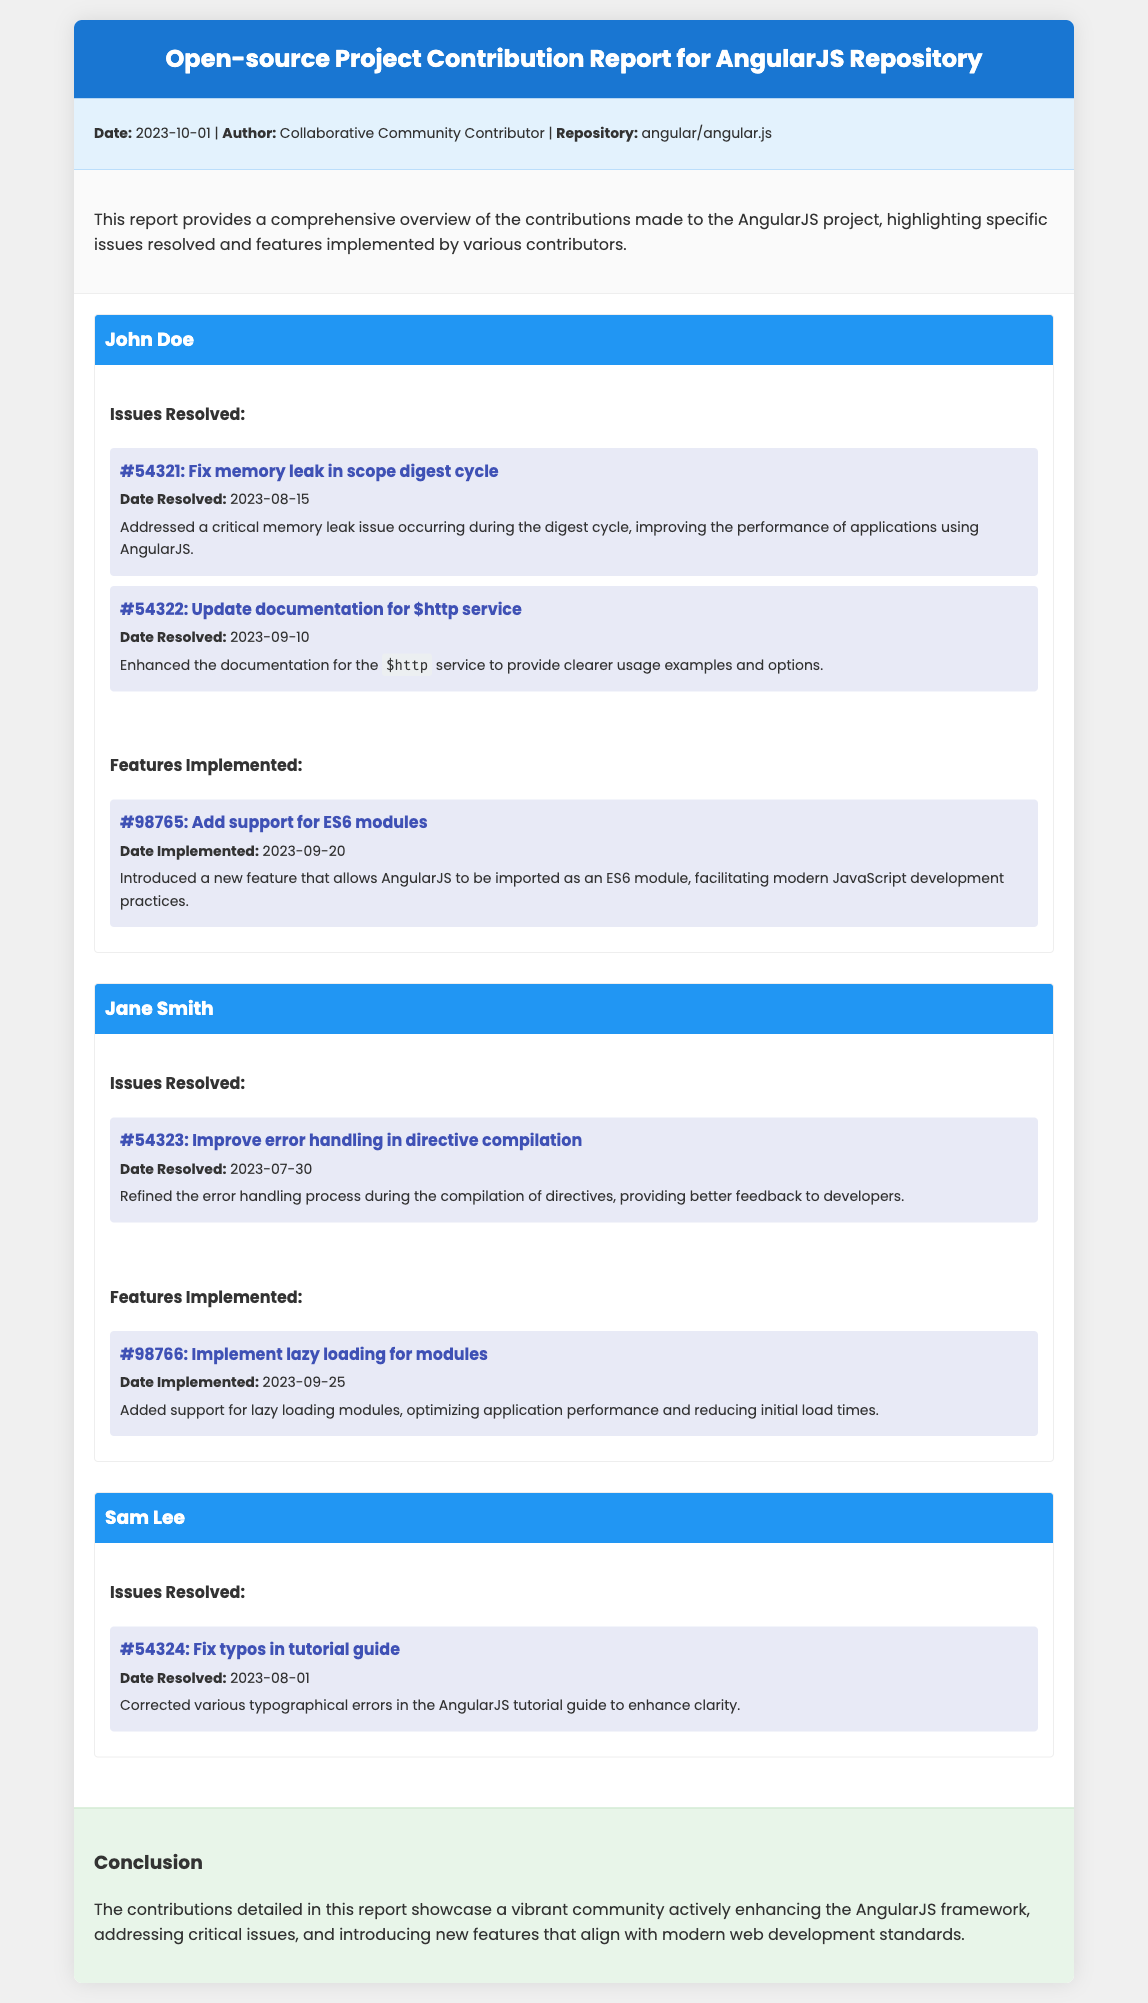What is the date of the report? The date of the report is clearly stated in the meta-info section.
Answer: 2023-10-01 Who resolved the issue related to the memory leak? The contributor who resolved the memory leak issue is mentioned under issues resolved.
Answer: John Doe How many issues did Jane Smith resolve? The number of issues resolved by Jane Smith can be found in her contributions section.
Answer: 1 What feature was added by Sam Lee? The feature added by Sam Lee would be detailed under features implemented in his contribution.
Answer: None What is the title of the report? The title of the document is shown in the header section.
Answer: Open-source Project Contribution Report for AngularJS Repository What was the date when lazy loading support was implemented? The date is found in the features implemented section under Jane Smith's contribution.
Answer: 2023-09-25 Which contributor improved error handling in directive compilation? The contributor's name who made this improvement is specified in the issues resolved section.
Answer: Jane Smith How many features did John Doe implement? The number of features implemented by John Doe can be counted in his features section.
Answer: 1 What was the conclusion of the report? The conclusion summarizing the contributions can be found in the conclusion section.
Answer: A vibrant community actively enhancing the AngularJS framework 